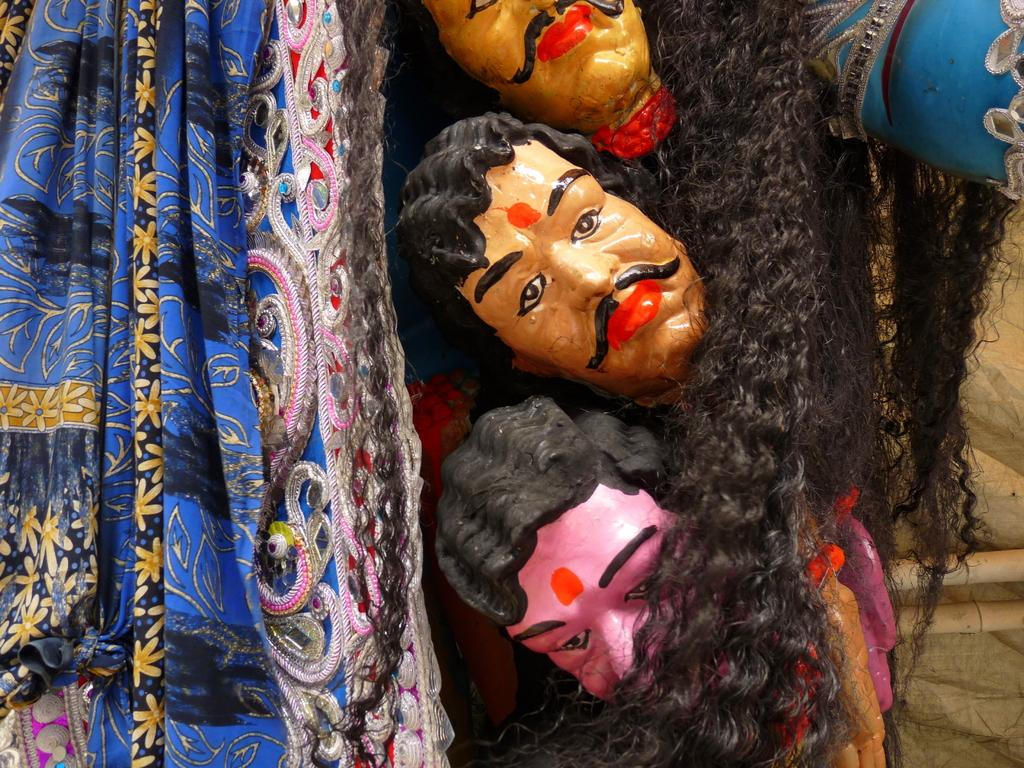What type of objects can be seen in the image? There are statues in the image. What material is draped over one of the statues? There is a cloth visible in the image. What physical feature can be seen on one of the statues? Hair is present in the image. What type of sock is visible on the statue in the image? There is no sock present on the statue in the image. What type of garden can be seen surrounding the statues in the image? There is no garden present in the image; it only features statues, a cloth, and hair. 